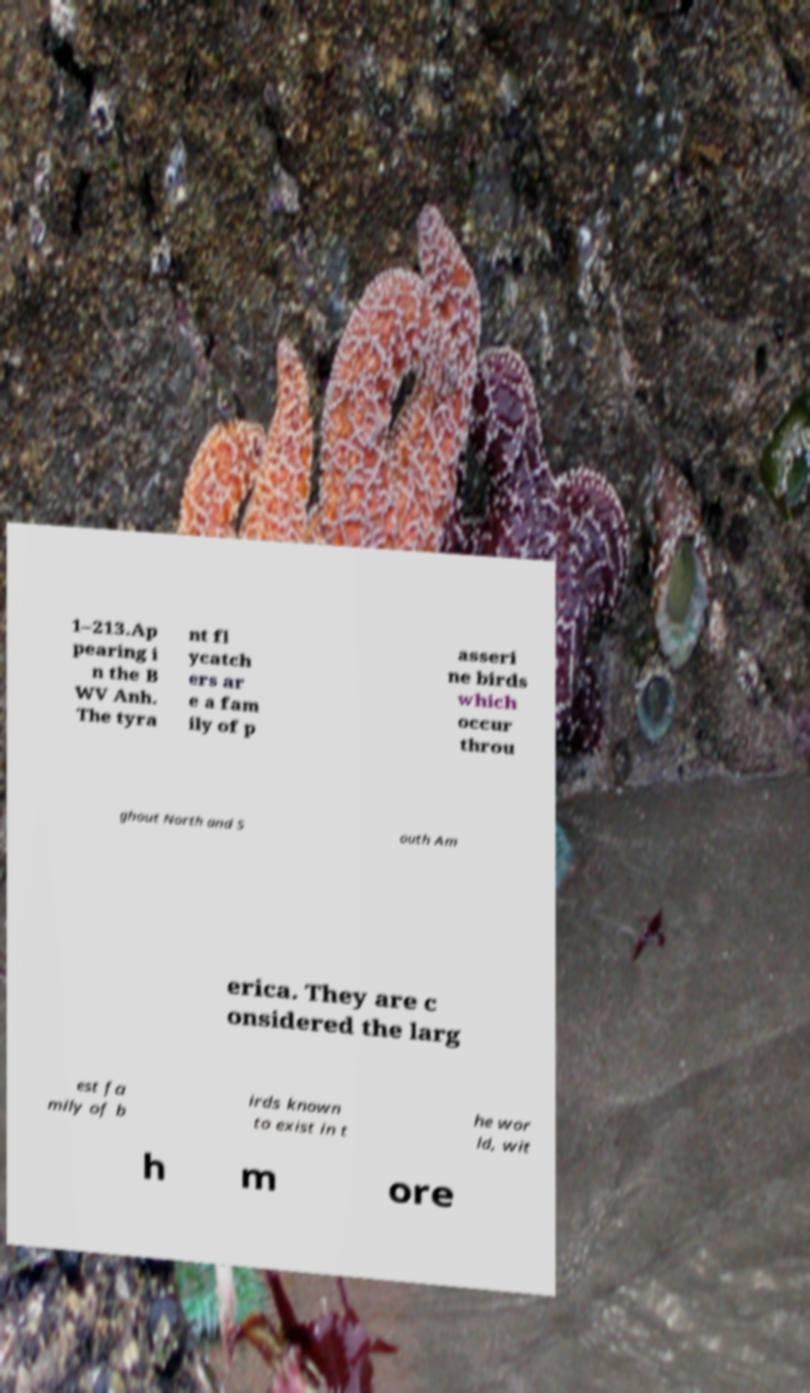Please read and relay the text visible in this image. What does it say? 1–213.Ap pearing i n the B WV Anh. The tyra nt fl ycatch ers ar e a fam ily of p asseri ne birds which occur throu ghout North and S outh Am erica. They are c onsidered the larg est fa mily of b irds known to exist in t he wor ld, wit h m ore 